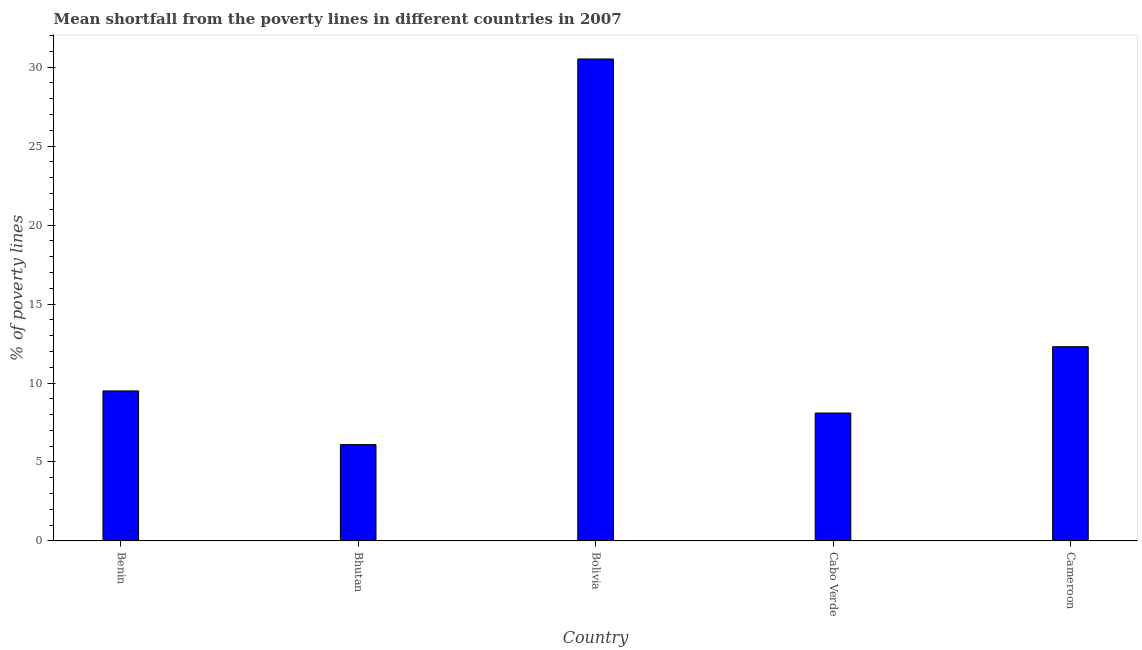Does the graph contain any zero values?
Offer a very short reply. No. Does the graph contain grids?
Your answer should be compact. No. What is the title of the graph?
Your answer should be compact. Mean shortfall from the poverty lines in different countries in 2007. What is the label or title of the X-axis?
Ensure brevity in your answer.  Country. What is the label or title of the Y-axis?
Your answer should be compact. % of poverty lines. What is the poverty gap at national poverty lines in Bolivia?
Provide a succinct answer. 30.52. Across all countries, what is the maximum poverty gap at national poverty lines?
Offer a very short reply. 30.52. Across all countries, what is the minimum poverty gap at national poverty lines?
Your response must be concise. 6.1. In which country was the poverty gap at national poverty lines maximum?
Your answer should be compact. Bolivia. In which country was the poverty gap at national poverty lines minimum?
Offer a terse response. Bhutan. What is the sum of the poverty gap at national poverty lines?
Provide a succinct answer. 66.52. What is the average poverty gap at national poverty lines per country?
Keep it short and to the point. 13.3. What is the median poverty gap at national poverty lines?
Provide a succinct answer. 9.5. What is the ratio of the poverty gap at national poverty lines in Benin to that in Bhutan?
Provide a succinct answer. 1.56. Is the difference between the poverty gap at national poverty lines in Benin and Cameroon greater than the difference between any two countries?
Make the answer very short. No. What is the difference between the highest and the second highest poverty gap at national poverty lines?
Your answer should be compact. 18.22. What is the difference between the highest and the lowest poverty gap at national poverty lines?
Keep it short and to the point. 24.42. In how many countries, is the poverty gap at national poverty lines greater than the average poverty gap at national poverty lines taken over all countries?
Offer a terse response. 1. Are all the bars in the graph horizontal?
Your answer should be compact. No. How many countries are there in the graph?
Make the answer very short. 5. What is the difference between two consecutive major ticks on the Y-axis?
Provide a succinct answer. 5. Are the values on the major ticks of Y-axis written in scientific E-notation?
Give a very brief answer. No. What is the % of poverty lines of Benin?
Give a very brief answer. 9.5. What is the % of poverty lines of Bolivia?
Your answer should be very brief. 30.52. What is the difference between the % of poverty lines in Benin and Bhutan?
Provide a short and direct response. 3.4. What is the difference between the % of poverty lines in Benin and Bolivia?
Keep it short and to the point. -21.02. What is the difference between the % of poverty lines in Benin and Cabo Verde?
Your answer should be compact. 1.4. What is the difference between the % of poverty lines in Benin and Cameroon?
Make the answer very short. -2.8. What is the difference between the % of poverty lines in Bhutan and Bolivia?
Ensure brevity in your answer.  -24.42. What is the difference between the % of poverty lines in Bolivia and Cabo Verde?
Provide a succinct answer. 22.42. What is the difference between the % of poverty lines in Bolivia and Cameroon?
Give a very brief answer. 18.22. What is the difference between the % of poverty lines in Cabo Verde and Cameroon?
Ensure brevity in your answer.  -4.2. What is the ratio of the % of poverty lines in Benin to that in Bhutan?
Provide a succinct answer. 1.56. What is the ratio of the % of poverty lines in Benin to that in Bolivia?
Your answer should be compact. 0.31. What is the ratio of the % of poverty lines in Benin to that in Cabo Verde?
Keep it short and to the point. 1.17. What is the ratio of the % of poverty lines in Benin to that in Cameroon?
Your answer should be compact. 0.77. What is the ratio of the % of poverty lines in Bhutan to that in Cabo Verde?
Ensure brevity in your answer.  0.75. What is the ratio of the % of poverty lines in Bhutan to that in Cameroon?
Offer a very short reply. 0.5. What is the ratio of the % of poverty lines in Bolivia to that in Cabo Verde?
Provide a succinct answer. 3.77. What is the ratio of the % of poverty lines in Bolivia to that in Cameroon?
Your answer should be very brief. 2.48. What is the ratio of the % of poverty lines in Cabo Verde to that in Cameroon?
Offer a terse response. 0.66. 